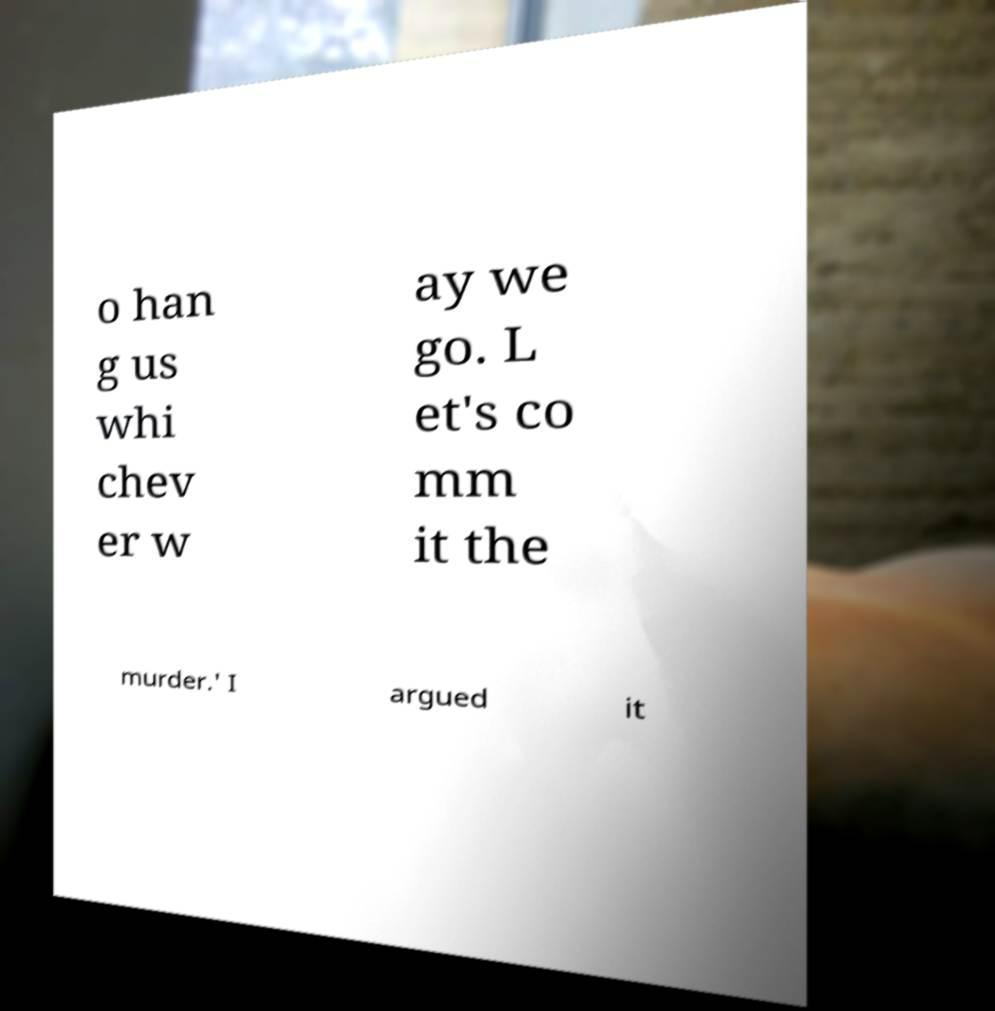There's text embedded in this image that I need extracted. Can you transcribe it verbatim? o han g us whi chev er w ay we go. L et's co mm it the murder.' I argued it 